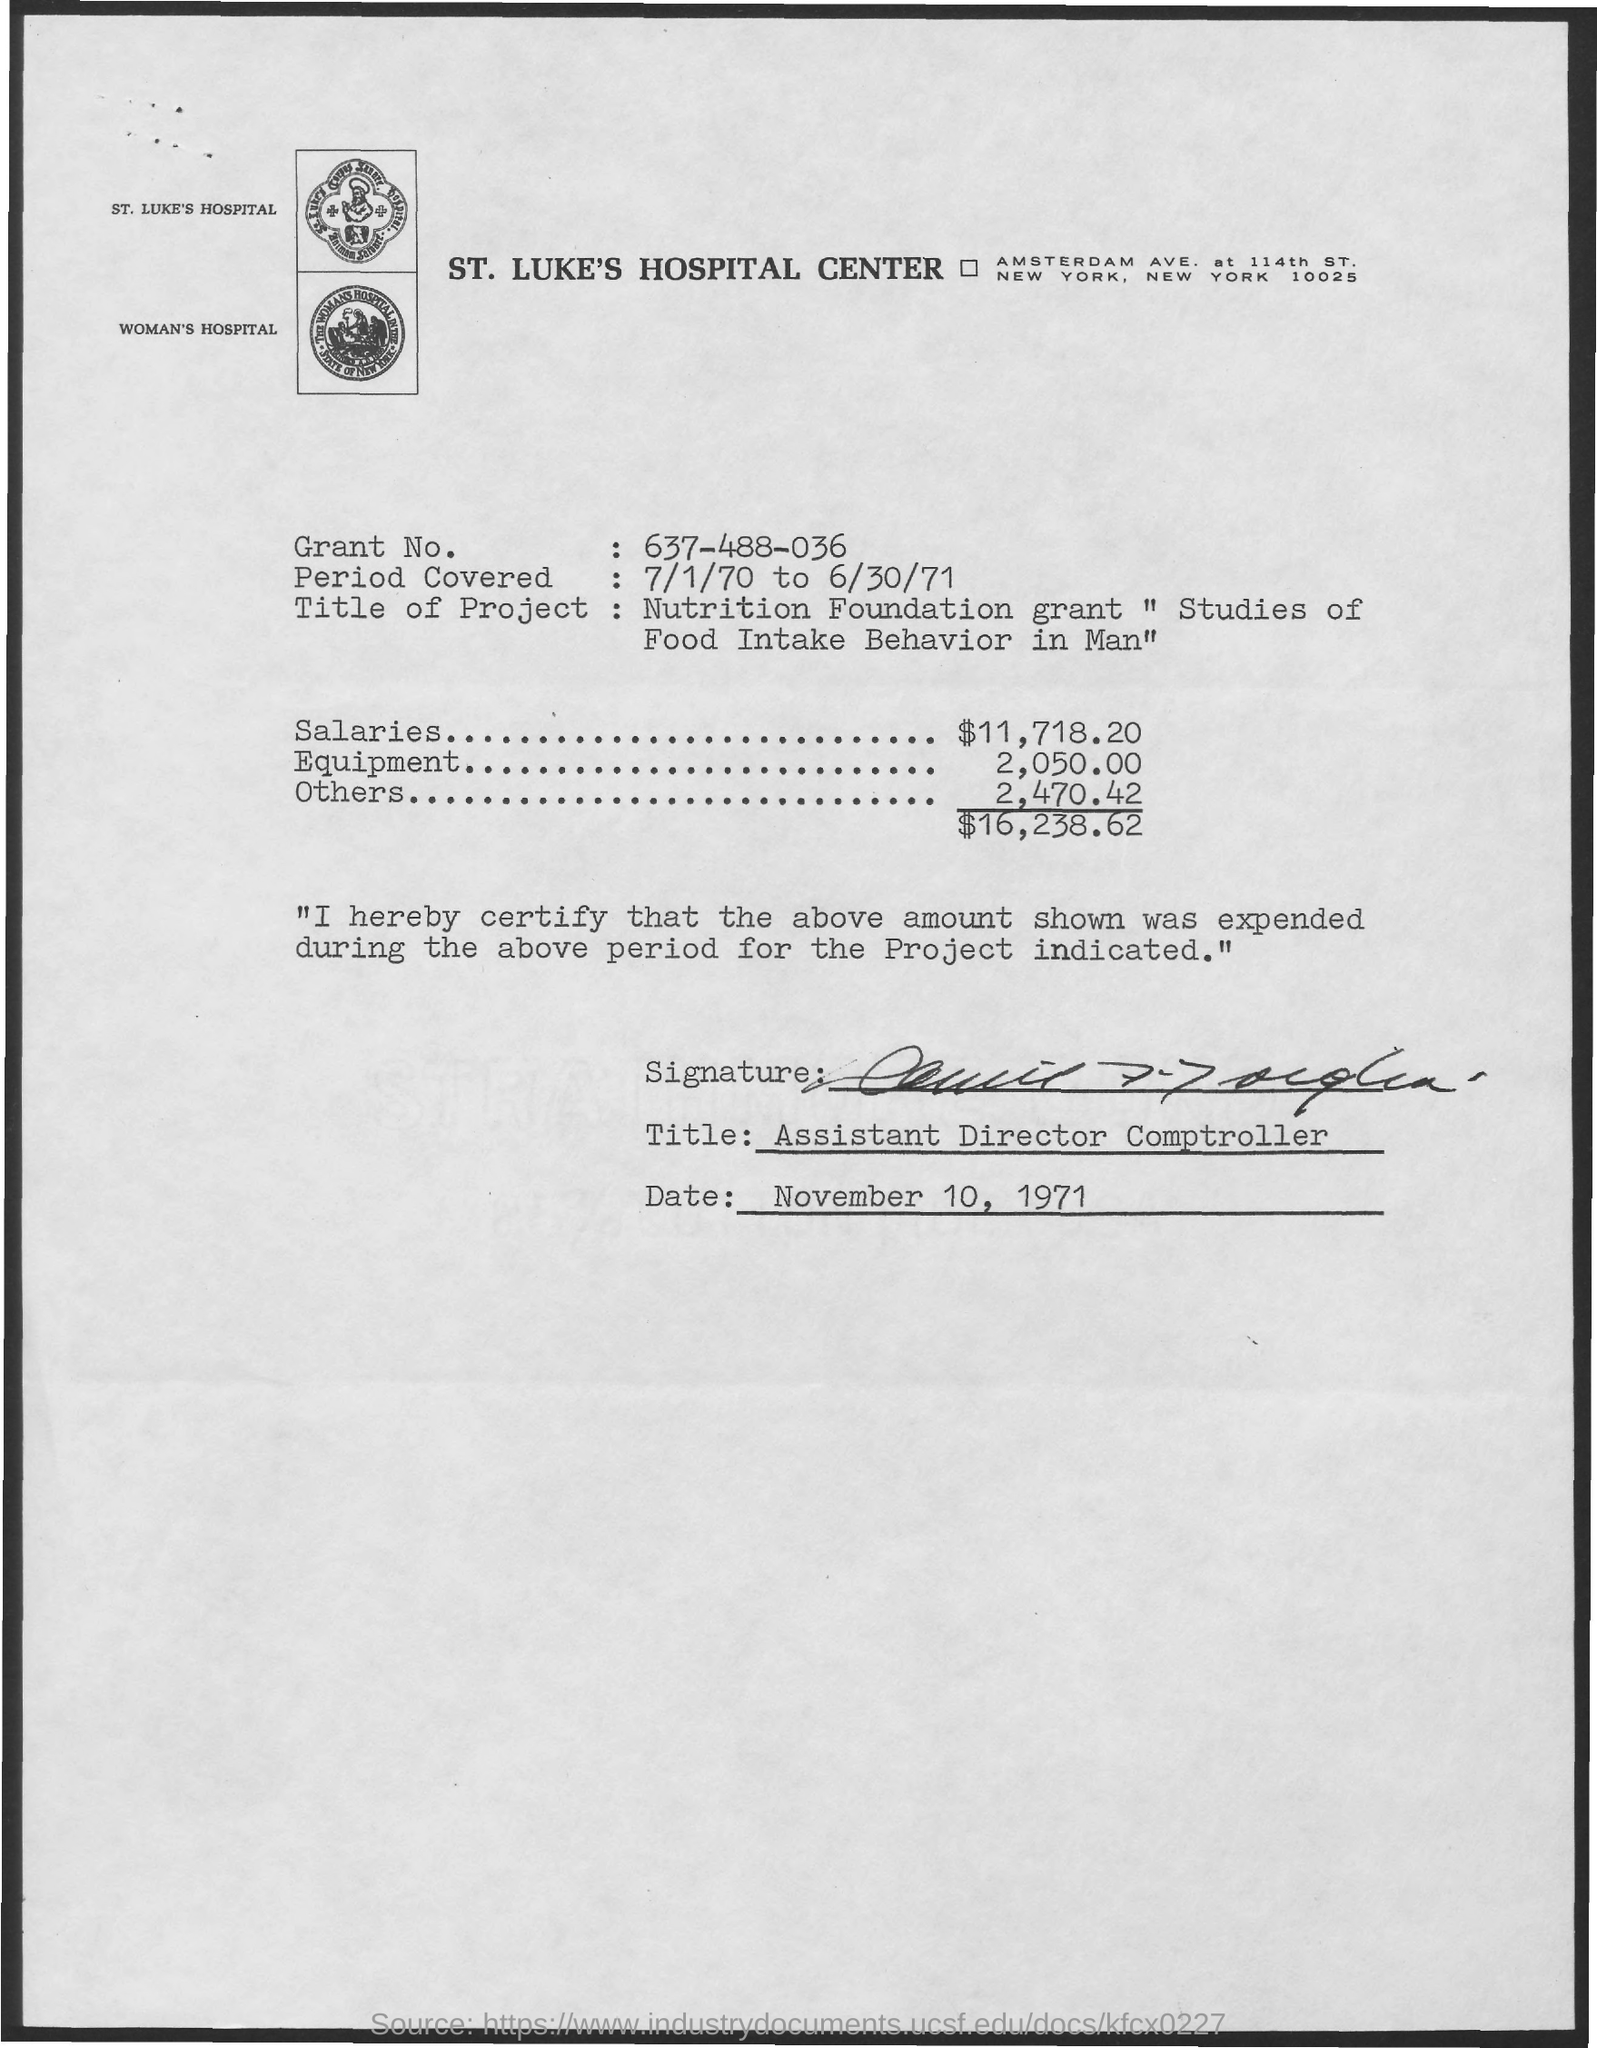Point out several critical features in this image. The date mentioned at the bottom is November 10, 1971. The title mentioned at the bottom is "Assistant Director of Comptroller. The equipment mentioned in this document is priced at 2,050.00. The hospital center named St. Luke's Hospital Center... 